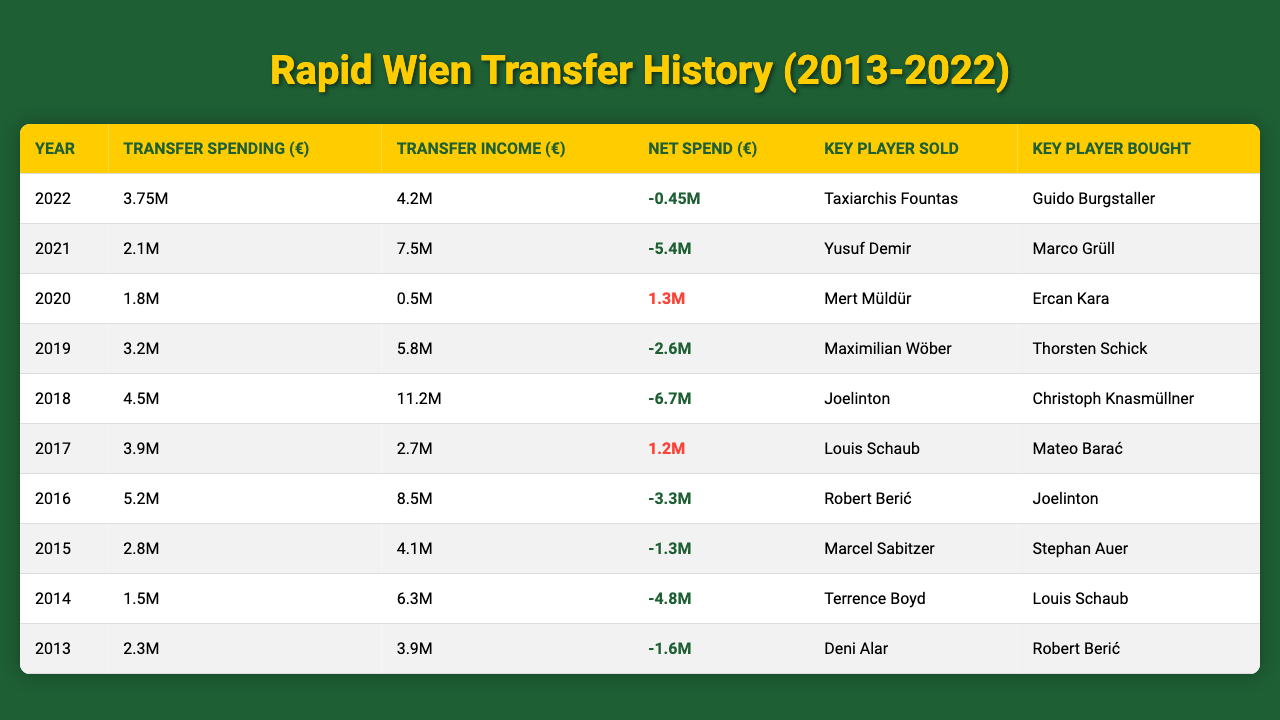What was Rapid Wien's transfer spending in 2022? The value in the "Transfer Spending (€)" column for the year 2022 is 3.75 million euros.
Answer: 3.75M Who was the key player sold in 2021? The player listed under "Key Player Sold" for the year 2021 is Yusuf Demir.
Answer: Yusuf Demir What is the net spend for 2016? The net spend for 2016 is -3.3 million euros, which is indicated in the "Net Spend (€)" column.
Answer: -3.3M In which year did Rapid Wien have the highest transfer income? The highest transfer income is recorded for 2018 at 11.2 million euros, which is the highest figure in the "Transfer Income (€)" column.
Answer: 2018 What was the total transfer spending from 2013 to 2022? The sum of the transfer spending from 2013 to 2022 is calculated as follows: 2.3M + 1.5M + 2.8M + 5.2M + 3.9M + 4.5M + 3.2M + 1.8M + 2.1M + 3.75M = 28.05M euros.
Answer: 28.05M Was there a year in which Rapid Wien made a net profit on transfers? Yes, in the year 2020, the net spend is positive at 1.3 million euros, indicating a profit from transfers.
Answer: Yes How many key players were bought in 2019 and 2020 combined? The number of key players bought in 2019 is 1 (Thorsten Schick) and in 2020 is 1 (Ercan Kara). So 1 + 1 equals 2 key players bought in total for those years.
Answer: 2 What was the average transfer income over the decade? The total transfer income is 4.2M + 7.5M + 0.5M + 5.8M + 11.2M + 2.7M + 8.5M + 4.1M + 6.3M + 3.9M = 54.6M euros. There are 10 data points, so the average is 54.6M / 10 = 5.46M euros.
Answer: 5.46M Which year had the lowest net spend? The year with the lowest net spend is 2018, which shows a net spend of -6.7 million euros in the table.
Answer: 2018 Was the key player bought in 2017 also sold in 2018? No, the key player bought in 2017 was Mateo Barać, and the key player sold in 2018 was Joelinton, so they are different players.
Answer: No 